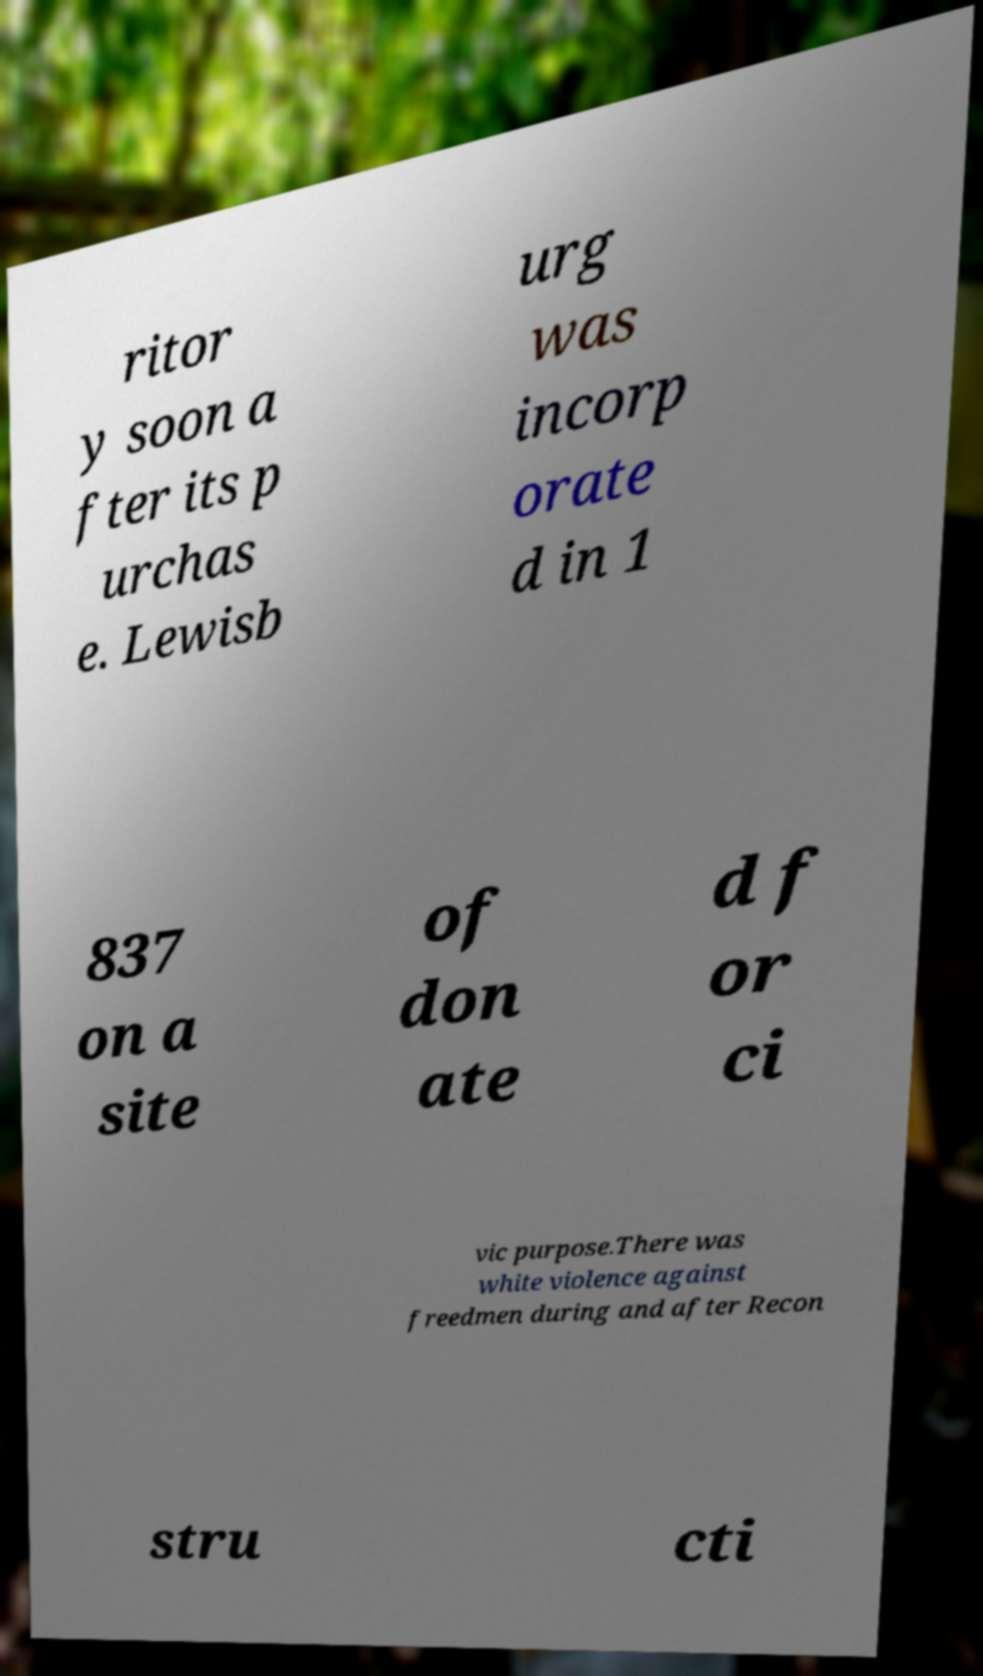Can you read and provide the text displayed in the image?This photo seems to have some interesting text. Can you extract and type it out for me? ritor y soon a fter its p urchas e. Lewisb urg was incorp orate d in 1 837 on a site of don ate d f or ci vic purpose.There was white violence against freedmen during and after Recon stru cti 